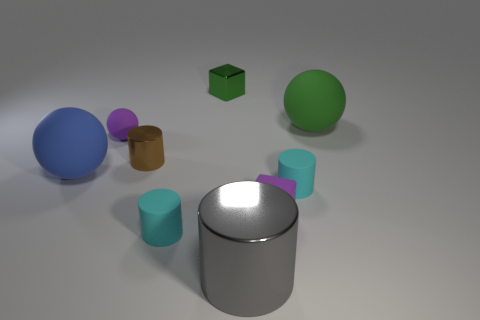Subtract 1 cylinders. How many cylinders are left? 3 Subtract all brown blocks. Subtract all yellow cylinders. How many blocks are left? 2 Add 1 blue matte objects. How many objects exist? 10 Subtract all balls. How many objects are left? 6 Subtract all purple objects. Subtract all purple spheres. How many objects are left? 6 Add 3 big blue rubber things. How many big blue rubber things are left? 4 Add 5 big green rubber things. How many big green rubber things exist? 6 Subtract 0 cyan balls. How many objects are left? 9 